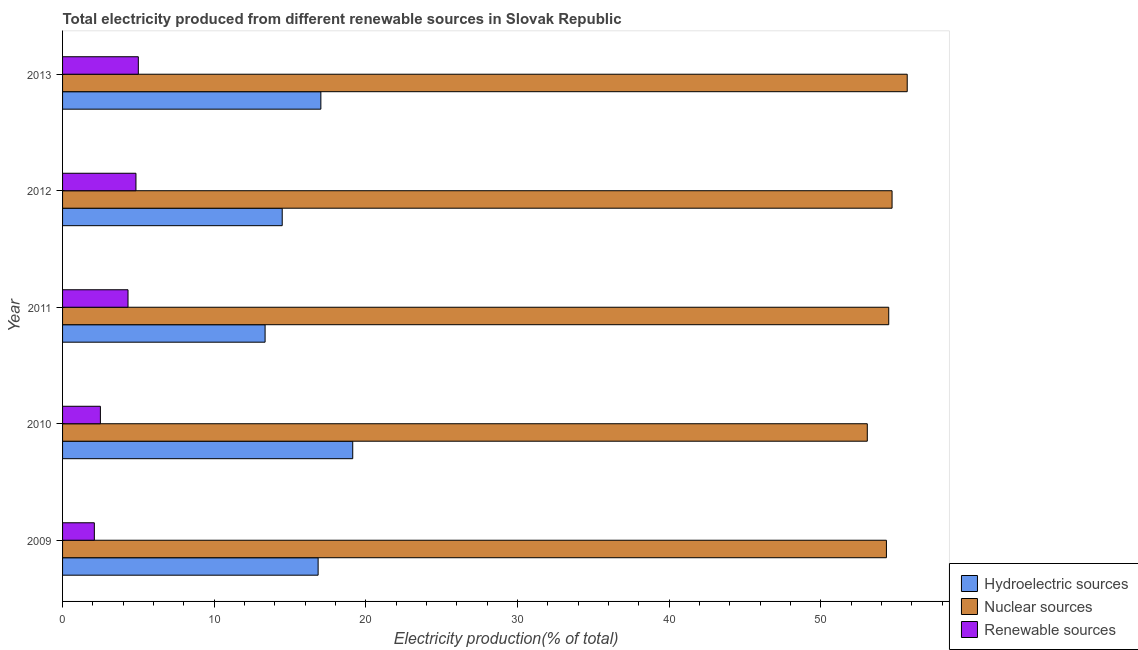Are the number of bars on each tick of the Y-axis equal?
Your answer should be very brief. Yes. How many bars are there on the 3rd tick from the bottom?
Your answer should be very brief. 3. What is the percentage of electricity produced by hydroelectric sources in 2013?
Your answer should be compact. 17.03. Across all years, what is the maximum percentage of electricity produced by renewable sources?
Your answer should be very brief. 5. Across all years, what is the minimum percentage of electricity produced by nuclear sources?
Offer a very short reply. 53.07. In which year was the percentage of electricity produced by nuclear sources minimum?
Provide a succinct answer. 2010. What is the total percentage of electricity produced by nuclear sources in the graph?
Offer a very short reply. 272.27. What is the difference between the percentage of electricity produced by renewable sources in 2010 and that in 2013?
Your answer should be very brief. -2.5. What is the difference between the percentage of electricity produced by nuclear sources in 2010 and the percentage of electricity produced by renewable sources in 2013?
Give a very brief answer. 48.07. What is the average percentage of electricity produced by renewable sources per year?
Provide a short and direct response. 3.75. In the year 2010, what is the difference between the percentage of electricity produced by hydroelectric sources and percentage of electricity produced by renewable sources?
Give a very brief answer. 16.64. In how many years, is the percentage of electricity produced by hydroelectric sources greater than 30 %?
Provide a succinct answer. 0. What is the ratio of the percentage of electricity produced by renewable sources in 2010 to that in 2012?
Your answer should be very brief. 0.52. What is the difference between the highest and the second highest percentage of electricity produced by nuclear sources?
Provide a short and direct response. 1. Is the sum of the percentage of electricity produced by nuclear sources in 2011 and 2013 greater than the maximum percentage of electricity produced by hydroelectric sources across all years?
Give a very brief answer. Yes. What does the 1st bar from the top in 2012 represents?
Provide a short and direct response. Renewable sources. What does the 3rd bar from the bottom in 2013 represents?
Offer a terse response. Renewable sources. Is it the case that in every year, the sum of the percentage of electricity produced by hydroelectric sources and percentage of electricity produced by nuclear sources is greater than the percentage of electricity produced by renewable sources?
Your response must be concise. Yes. How many bars are there?
Your response must be concise. 15. Are the values on the major ticks of X-axis written in scientific E-notation?
Keep it short and to the point. No. Does the graph contain any zero values?
Your response must be concise. No. Does the graph contain grids?
Offer a terse response. No. Where does the legend appear in the graph?
Your answer should be compact. Bottom right. How many legend labels are there?
Your answer should be compact. 3. What is the title of the graph?
Offer a terse response. Total electricity produced from different renewable sources in Slovak Republic. What is the label or title of the X-axis?
Your answer should be compact. Electricity production(% of total). What is the Electricity production(% of total) in Hydroelectric sources in 2009?
Provide a succinct answer. 16.85. What is the Electricity production(% of total) of Nuclear sources in 2009?
Your response must be concise. 54.33. What is the Electricity production(% of total) in Renewable sources in 2009?
Your answer should be very brief. 2.09. What is the Electricity production(% of total) of Hydroelectric sources in 2010?
Your answer should be very brief. 19.13. What is the Electricity production(% of total) of Nuclear sources in 2010?
Ensure brevity in your answer.  53.07. What is the Electricity production(% of total) in Renewable sources in 2010?
Provide a short and direct response. 2.49. What is the Electricity production(% of total) in Hydroelectric sources in 2011?
Give a very brief answer. 13.36. What is the Electricity production(% of total) in Nuclear sources in 2011?
Offer a terse response. 54.48. What is the Electricity production(% of total) of Renewable sources in 2011?
Ensure brevity in your answer.  4.32. What is the Electricity production(% of total) in Hydroelectric sources in 2012?
Offer a terse response. 14.48. What is the Electricity production(% of total) of Nuclear sources in 2012?
Offer a terse response. 54.7. What is the Electricity production(% of total) of Renewable sources in 2012?
Provide a succinct answer. 4.84. What is the Electricity production(% of total) of Hydroelectric sources in 2013?
Your answer should be compact. 17.03. What is the Electricity production(% of total) in Nuclear sources in 2013?
Give a very brief answer. 55.7. What is the Electricity production(% of total) of Renewable sources in 2013?
Give a very brief answer. 5. Across all years, what is the maximum Electricity production(% of total) in Hydroelectric sources?
Your response must be concise. 19.13. Across all years, what is the maximum Electricity production(% of total) in Nuclear sources?
Ensure brevity in your answer.  55.7. Across all years, what is the maximum Electricity production(% of total) of Renewable sources?
Your response must be concise. 5. Across all years, what is the minimum Electricity production(% of total) of Hydroelectric sources?
Keep it short and to the point. 13.36. Across all years, what is the minimum Electricity production(% of total) of Nuclear sources?
Offer a very short reply. 53.07. Across all years, what is the minimum Electricity production(% of total) of Renewable sources?
Offer a very short reply. 2.09. What is the total Electricity production(% of total) of Hydroelectric sources in the graph?
Provide a succinct answer. 80.86. What is the total Electricity production(% of total) of Nuclear sources in the graph?
Your response must be concise. 272.27. What is the total Electricity production(% of total) of Renewable sources in the graph?
Provide a succinct answer. 18.74. What is the difference between the Electricity production(% of total) in Hydroelectric sources in 2009 and that in 2010?
Offer a terse response. -2.28. What is the difference between the Electricity production(% of total) of Nuclear sources in 2009 and that in 2010?
Offer a very short reply. 1.26. What is the difference between the Electricity production(% of total) of Renewable sources in 2009 and that in 2010?
Make the answer very short. -0.4. What is the difference between the Electricity production(% of total) in Hydroelectric sources in 2009 and that in 2011?
Provide a succinct answer. 3.5. What is the difference between the Electricity production(% of total) in Nuclear sources in 2009 and that in 2011?
Ensure brevity in your answer.  -0.15. What is the difference between the Electricity production(% of total) of Renewable sources in 2009 and that in 2011?
Keep it short and to the point. -2.22. What is the difference between the Electricity production(% of total) in Hydroelectric sources in 2009 and that in 2012?
Provide a short and direct response. 2.37. What is the difference between the Electricity production(% of total) of Nuclear sources in 2009 and that in 2012?
Give a very brief answer. -0.37. What is the difference between the Electricity production(% of total) of Renewable sources in 2009 and that in 2012?
Ensure brevity in your answer.  -2.74. What is the difference between the Electricity production(% of total) in Hydroelectric sources in 2009 and that in 2013?
Provide a succinct answer. -0.18. What is the difference between the Electricity production(% of total) of Nuclear sources in 2009 and that in 2013?
Your answer should be very brief. -1.37. What is the difference between the Electricity production(% of total) in Renewable sources in 2009 and that in 2013?
Offer a very short reply. -2.9. What is the difference between the Electricity production(% of total) of Hydroelectric sources in 2010 and that in 2011?
Your answer should be compact. 5.78. What is the difference between the Electricity production(% of total) of Nuclear sources in 2010 and that in 2011?
Offer a very short reply. -1.41. What is the difference between the Electricity production(% of total) of Renewable sources in 2010 and that in 2011?
Provide a short and direct response. -1.82. What is the difference between the Electricity production(% of total) of Hydroelectric sources in 2010 and that in 2012?
Give a very brief answer. 4.65. What is the difference between the Electricity production(% of total) in Nuclear sources in 2010 and that in 2012?
Offer a terse response. -1.63. What is the difference between the Electricity production(% of total) of Renewable sources in 2010 and that in 2012?
Your answer should be compact. -2.35. What is the difference between the Electricity production(% of total) of Hydroelectric sources in 2010 and that in 2013?
Offer a terse response. 2.1. What is the difference between the Electricity production(% of total) in Nuclear sources in 2010 and that in 2013?
Your response must be concise. -2.63. What is the difference between the Electricity production(% of total) in Renewable sources in 2010 and that in 2013?
Offer a very short reply. -2.5. What is the difference between the Electricity production(% of total) of Hydroelectric sources in 2011 and that in 2012?
Offer a very short reply. -1.13. What is the difference between the Electricity production(% of total) of Nuclear sources in 2011 and that in 2012?
Your answer should be compact. -0.22. What is the difference between the Electricity production(% of total) in Renewable sources in 2011 and that in 2012?
Ensure brevity in your answer.  -0.52. What is the difference between the Electricity production(% of total) in Hydroelectric sources in 2011 and that in 2013?
Offer a very short reply. -3.68. What is the difference between the Electricity production(% of total) of Nuclear sources in 2011 and that in 2013?
Provide a succinct answer. -1.22. What is the difference between the Electricity production(% of total) of Renewable sources in 2011 and that in 2013?
Keep it short and to the point. -0.68. What is the difference between the Electricity production(% of total) of Hydroelectric sources in 2012 and that in 2013?
Your response must be concise. -2.55. What is the difference between the Electricity production(% of total) of Nuclear sources in 2012 and that in 2013?
Make the answer very short. -1. What is the difference between the Electricity production(% of total) in Renewable sources in 2012 and that in 2013?
Provide a succinct answer. -0.16. What is the difference between the Electricity production(% of total) of Hydroelectric sources in 2009 and the Electricity production(% of total) of Nuclear sources in 2010?
Your response must be concise. -36.21. What is the difference between the Electricity production(% of total) of Hydroelectric sources in 2009 and the Electricity production(% of total) of Renewable sources in 2010?
Keep it short and to the point. 14.36. What is the difference between the Electricity production(% of total) in Nuclear sources in 2009 and the Electricity production(% of total) in Renewable sources in 2010?
Your answer should be compact. 51.83. What is the difference between the Electricity production(% of total) in Hydroelectric sources in 2009 and the Electricity production(% of total) in Nuclear sources in 2011?
Offer a very short reply. -37.63. What is the difference between the Electricity production(% of total) in Hydroelectric sources in 2009 and the Electricity production(% of total) in Renewable sources in 2011?
Provide a short and direct response. 12.54. What is the difference between the Electricity production(% of total) in Nuclear sources in 2009 and the Electricity production(% of total) in Renewable sources in 2011?
Offer a very short reply. 50.01. What is the difference between the Electricity production(% of total) in Hydroelectric sources in 2009 and the Electricity production(% of total) in Nuclear sources in 2012?
Offer a terse response. -37.85. What is the difference between the Electricity production(% of total) of Hydroelectric sources in 2009 and the Electricity production(% of total) of Renewable sources in 2012?
Your answer should be compact. 12.01. What is the difference between the Electricity production(% of total) of Nuclear sources in 2009 and the Electricity production(% of total) of Renewable sources in 2012?
Give a very brief answer. 49.49. What is the difference between the Electricity production(% of total) of Hydroelectric sources in 2009 and the Electricity production(% of total) of Nuclear sources in 2013?
Give a very brief answer. -38.85. What is the difference between the Electricity production(% of total) of Hydroelectric sources in 2009 and the Electricity production(% of total) of Renewable sources in 2013?
Provide a short and direct response. 11.86. What is the difference between the Electricity production(% of total) in Nuclear sources in 2009 and the Electricity production(% of total) in Renewable sources in 2013?
Provide a succinct answer. 49.33. What is the difference between the Electricity production(% of total) in Hydroelectric sources in 2010 and the Electricity production(% of total) in Nuclear sources in 2011?
Your answer should be compact. -35.34. What is the difference between the Electricity production(% of total) of Hydroelectric sources in 2010 and the Electricity production(% of total) of Renewable sources in 2011?
Give a very brief answer. 14.82. What is the difference between the Electricity production(% of total) in Nuclear sources in 2010 and the Electricity production(% of total) in Renewable sources in 2011?
Ensure brevity in your answer.  48.75. What is the difference between the Electricity production(% of total) of Hydroelectric sources in 2010 and the Electricity production(% of total) of Nuclear sources in 2012?
Ensure brevity in your answer.  -35.56. What is the difference between the Electricity production(% of total) in Hydroelectric sources in 2010 and the Electricity production(% of total) in Renewable sources in 2012?
Provide a short and direct response. 14.29. What is the difference between the Electricity production(% of total) of Nuclear sources in 2010 and the Electricity production(% of total) of Renewable sources in 2012?
Your answer should be compact. 48.23. What is the difference between the Electricity production(% of total) of Hydroelectric sources in 2010 and the Electricity production(% of total) of Nuclear sources in 2013?
Offer a terse response. -36.56. What is the difference between the Electricity production(% of total) in Hydroelectric sources in 2010 and the Electricity production(% of total) in Renewable sources in 2013?
Keep it short and to the point. 14.14. What is the difference between the Electricity production(% of total) of Nuclear sources in 2010 and the Electricity production(% of total) of Renewable sources in 2013?
Offer a terse response. 48.07. What is the difference between the Electricity production(% of total) of Hydroelectric sources in 2011 and the Electricity production(% of total) of Nuclear sources in 2012?
Your answer should be compact. -41.34. What is the difference between the Electricity production(% of total) of Hydroelectric sources in 2011 and the Electricity production(% of total) of Renewable sources in 2012?
Give a very brief answer. 8.52. What is the difference between the Electricity production(% of total) of Nuclear sources in 2011 and the Electricity production(% of total) of Renewable sources in 2012?
Provide a succinct answer. 49.64. What is the difference between the Electricity production(% of total) in Hydroelectric sources in 2011 and the Electricity production(% of total) in Nuclear sources in 2013?
Offer a terse response. -42.34. What is the difference between the Electricity production(% of total) in Hydroelectric sources in 2011 and the Electricity production(% of total) in Renewable sources in 2013?
Offer a terse response. 8.36. What is the difference between the Electricity production(% of total) of Nuclear sources in 2011 and the Electricity production(% of total) of Renewable sources in 2013?
Give a very brief answer. 49.48. What is the difference between the Electricity production(% of total) of Hydroelectric sources in 2012 and the Electricity production(% of total) of Nuclear sources in 2013?
Keep it short and to the point. -41.21. What is the difference between the Electricity production(% of total) of Hydroelectric sources in 2012 and the Electricity production(% of total) of Renewable sources in 2013?
Keep it short and to the point. 9.49. What is the difference between the Electricity production(% of total) in Nuclear sources in 2012 and the Electricity production(% of total) in Renewable sources in 2013?
Your response must be concise. 49.7. What is the average Electricity production(% of total) in Hydroelectric sources per year?
Offer a very short reply. 16.17. What is the average Electricity production(% of total) in Nuclear sources per year?
Your answer should be very brief. 54.45. What is the average Electricity production(% of total) in Renewable sources per year?
Your answer should be very brief. 3.75. In the year 2009, what is the difference between the Electricity production(% of total) in Hydroelectric sources and Electricity production(% of total) in Nuclear sources?
Give a very brief answer. -37.47. In the year 2009, what is the difference between the Electricity production(% of total) in Hydroelectric sources and Electricity production(% of total) in Renewable sources?
Your answer should be very brief. 14.76. In the year 2009, what is the difference between the Electricity production(% of total) in Nuclear sources and Electricity production(% of total) in Renewable sources?
Your response must be concise. 52.23. In the year 2010, what is the difference between the Electricity production(% of total) of Hydroelectric sources and Electricity production(% of total) of Nuclear sources?
Give a very brief answer. -33.93. In the year 2010, what is the difference between the Electricity production(% of total) of Hydroelectric sources and Electricity production(% of total) of Renewable sources?
Ensure brevity in your answer.  16.64. In the year 2010, what is the difference between the Electricity production(% of total) of Nuclear sources and Electricity production(% of total) of Renewable sources?
Make the answer very short. 50.57. In the year 2011, what is the difference between the Electricity production(% of total) in Hydroelectric sources and Electricity production(% of total) in Nuclear sources?
Your answer should be compact. -41.12. In the year 2011, what is the difference between the Electricity production(% of total) of Hydroelectric sources and Electricity production(% of total) of Renewable sources?
Make the answer very short. 9.04. In the year 2011, what is the difference between the Electricity production(% of total) in Nuclear sources and Electricity production(% of total) in Renewable sources?
Your answer should be very brief. 50.16. In the year 2012, what is the difference between the Electricity production(% of total) of Hydroelectric sources and Electricity production(% of total) of Nuclear sources?
Ensure brevity in your answer.  -40.21. In the year 2012, what is the difference between the Electricity production(% of total) of Hydroelectric sources and Electricity production(% of total) of Renewable sources?
Provide a succinct answer. 9.64. In the year 2012, what is the difference between the Electricity production(% of total) in Nuclear sources and Electricity production(% of total) in Renewable sources?
Offer a very short reply. 49.86. In the year 2013, what is the difference between the Electricity production(% of total) in Hydroelectric sources and Electricity production(% of total) in Nuclear sources?
Your answer should be very brief. -38.66. In the year 2013, what is the difference between the Electricity production(% of total) of Hydroelectric sources and Electricity production(% of total) of Renewable sources?
Keep it short and to the point. 12.04. In the year 2013, what is the difference between the Electricity production(% of total) of Nuclear sources and Electricity production(% of total) of Renewable sources?
Your answer should be compact. 50.7. What is the ratio of the Electricity production(% of total) in Hydroelectric sources in 2009 to that in 2010?
Give a very brief answer. 0.88. What is the ratio of the Electricity production(% of total) in Nuclear sources in 2009 to that in 2010?
Provide a short and direct response. 1.02. What is the ratio of the Electricity production(% of total) in Renewable sources in 2009 to that in 2010?
Give a very brief answer. 0.84. What is the ratio of the Electricity production(% of total) of Hydroelectric sources in 2009 to that in 2011?
Keep it short and to the point. 1.26. What is the ratio of the Electricity production(% of total) of Renewable sources in 2009 to that in 2011?
Provide a succinct answer. 0.49. What is the ratio of the Electricity production(% of total) in Hydroelectric sources in 2009 to that in 2012?
Give a very brief answer. 1.16. What is the ratio of the Electricity production(% of total) in Nuclear sources in 2009 to that in 2012?
Offer a very short reply. 0.99. What is the ratio of the Electricity production(% of total) of Renewable sources in 2009 to that in 2012?
Your answer should be very brief. 0.43. What is the ratio of the Electricity production(% of total) in Hydroelectric sources in 2009 to that in 2013?
Your answer should be compact. 0.99. What is the ratio of the Electricity production(% of total) in Nuclear sources in 2009 to that in 2013?
Ensure brevity in your answer.  0.98. What is the ratio of the Electricity production(% of total) in Renewable sources in 2009 to that in 2013?
Ensure brevity in your answer.  0.42. What is the ratio of the Electricity production(% of total) in Hydroelectric sources in 2010 to that in 2011?
Give a very brief answer. 1.43. What is the ratio of the Electricity production(% of total) of Nuclear sources in 2010 to that in 2011?
Make the answer very short. 0.97. What is the ratio of the Electricity production(% of total) in Renewable sources in 2010 to that in 2011?
Your answer should be compact. 0.58. What is the ratio of the Electricity production(% of total) in Hydroelectric sources in 2010 to that in 2012?
Your answer should be very brief. 1.32. What is the ratio of the Electricity production(% of total) of Nuclear sources in 2010 to that in 2012?
Ensure brevity in your answer.  0.97. What is the ratio of the Electricity production(% of total) in Renewable sources in 2010 to that in 2012?
Offer a very short reply. 0.52. What is the ratio of the Electricity production(% of total) of Hydroelectric sources in 2010 to that in 2013?
Provide a succinct answer. 1.12. What is the ratio of the Electricity production(% of total) of Nuclear sources in 2010 to that in 2013?
Offer a terse response. 0.95. What is the ratio of the Electricity production(% of total) of Renewable sources in 2010 to that in 2013?
Ensure brevity in your answer.  0.5. What is the ratio of the Electricity production(% of total) in Hydroelectric sources in 2011 to that in 2012?
Make the answer very short. 0.92. What is the ratio of the Electricity production(% of total) of Nuclear sources in 2011 to that in 2012?
Offer a very short reply. 1. What is the ratio of the Electricity production(% of total) of Renewable sources in 2011 to that in 2012?
Ensure brevity in your answer.  0.89. What is the ratio of the Electricity production(% of total) of Hydroelectric sources in 2011 to that in 2013?
Make the answer very short. 0.78. What is the ratio of the Electricity production(% of total) in Nuclear sources in 2011 to that in 2013?
Offer a very short reply. 0.98. What is the ratio of the Electricity production(% of total) of Renewable sources in 2011 to that in 2013?
Your answer should be compact. 0.86. What is the ratio of the Electricity production(% of total) of Hydroelectric sources in 2012 to that in 2013?
Offer a very short reply. 0.85. What is the ratio of the Electricity production(% of total) in Nuclear sources in 2012 to that in 2013?
Give a very brief answer. 0.98. What is the ratio of the Electricity production(% of total) in Renewable sources in 2012 to that in 2013?
Your answer should be compact. 0.97. What is the difference between the highest and the second highest Electricity production(% of total) of Hydroelectric sources?
Provide a short and direct response. 2.1. What is the difference between the highest and the second highest Electricity production(% of total) of Nuclear sources?
Your answer should be compact. 1. What is the difference between the highest and the second highest Electricity production(% of total) of Renewable sources?
Offer a terse response. 0.16. What is the difference between the highest and the lowest Electricity production(% of total) in Hydroelectric sources?
Offer a terse response. 5.78. What is the difference between the highest and the lowest Electricity production(% of total) of Nuclear sources?
Keep it short and to the point. 2.63. What is the difference between the highest and the lowest Electricity production(% of total) of Renewable sources?
Provide a short and direct response. 2.9. 